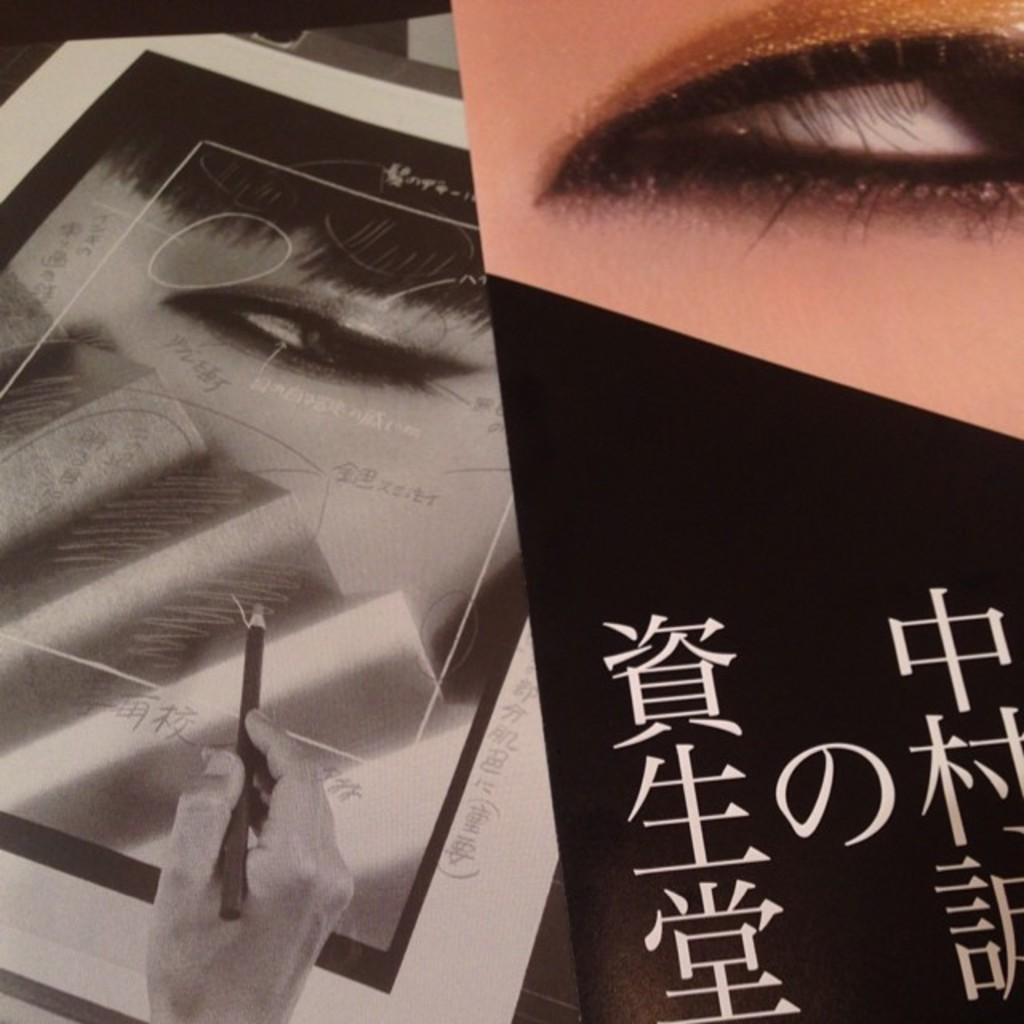Please provide a concise description of this image. This image is a collage image, in this image we can see the eye of a person with some text and in the other image we can see the hand of a person holding pencil on the poster. 